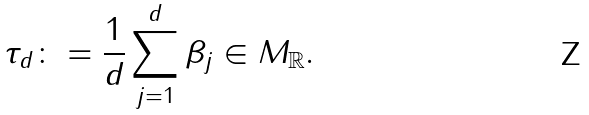<formula> <loc_0><loc_0><loc_500><loc_500>\tau _ { d } \colon = \frac { 1 } { d } \sum _ { j = 1 } ^ { d } \beta _ { j } \in M _ { \mathbb { R } } .</formula> 